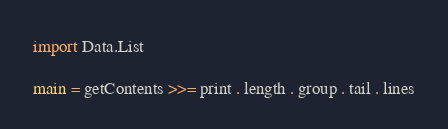Convert code to text. <code><loc_0><loc_0><loc_500><loc_500><_Haskell_>import Data.List

main = getContents >>= print . length . group . tail . lines</code> 